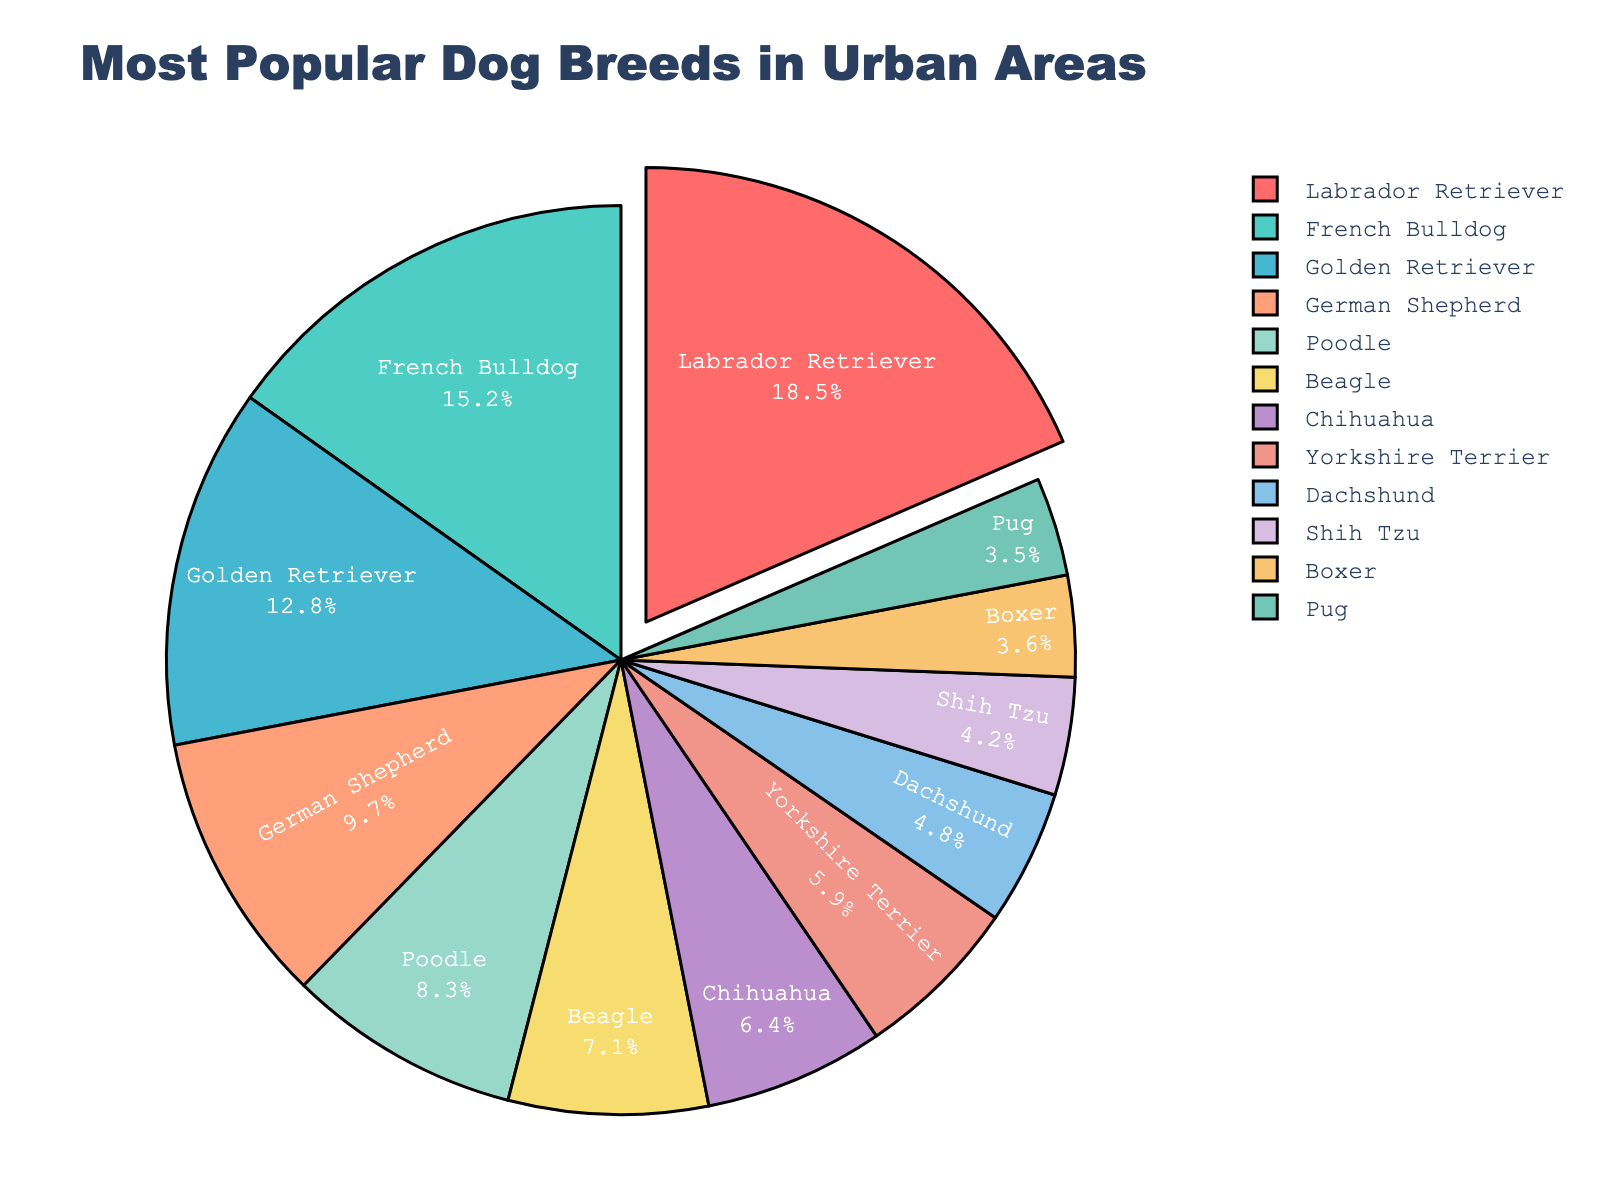Which breed is the most popular in urban areas? Look for the breed with the largest slice in the pie chart. The Labrador Retriever has the largest slice, which indicates it is the most popular breed.
Answer: Labrador Retriever Which two breeds combined have the lowest percentage of popularity? Identify the two smallest slices in the pie chart. The Pug and Boxer both have very small slices, and their combined percentage can be estimated based on their labels.
Answer: Pug and Boxer By how much is the percentage of French Bulldogs greater than that of Beagles? Locate the percentages for French Bulldogs and Beagles. Subtract the Beagles' percentage (7.1%) from the French Bulldogs' percentage (15.2%). The difference is 15.2% - 7.1%.
Answer: 8.1% Which breed is more popular: German Shepherd or Poodle, and by how much? Find the slices for German Shepherd and Poodle, then compare their percentages. German Shepherd has a percentage of 9.7%, and Poodle has 8.3%. The difference is 9.7% - 8.3%.
Answer: German Shepherd, 1.4% What is the total percentage of the top three most popular breeds? Identify the top three largest slices, which are Labrador Retriever (18.5%), French Bulldog (15.2%), and Golden Retriever (12.8%). Add these percentages together.
Answer: 46.5% Among the breeds listed, which one lies almost midway in popularity between the most popular and the least popular? Ascertain the most and least popular breeds (Labrador Retriever - 18.5% and Pug - 3.5%). Calculate the mid-value: (18.5% + 3.5%)/2 = 11%, and find the breed closest to this percentage, which is the Golden Retriever at 12.8%.
Answer: Golden Retriever How does the popularity of Boxers compare to that of Shih Tzus? Find the percentages for Boxer and Shih Tzu. Boxer has 3.6% and Shih Tzu has 4.2%. The difference is 4.2% - 3.6%.
Answer: Shih Tzu is more popular by 0.6% Which breeds collectively make up more than 50% of the total popularity? Sum up the percentages starting from the largest until the cumulative percentage exceeds 50%. Labrador Retriever (18.5%), French Bulldog (15.2%), Golden Retriever (12.8%), and German Shepherd (9.7%) collectively exceed 50%.
Answer: Labrador Retriever, French Bulldog, Golden Retriever, and German Shepherd 